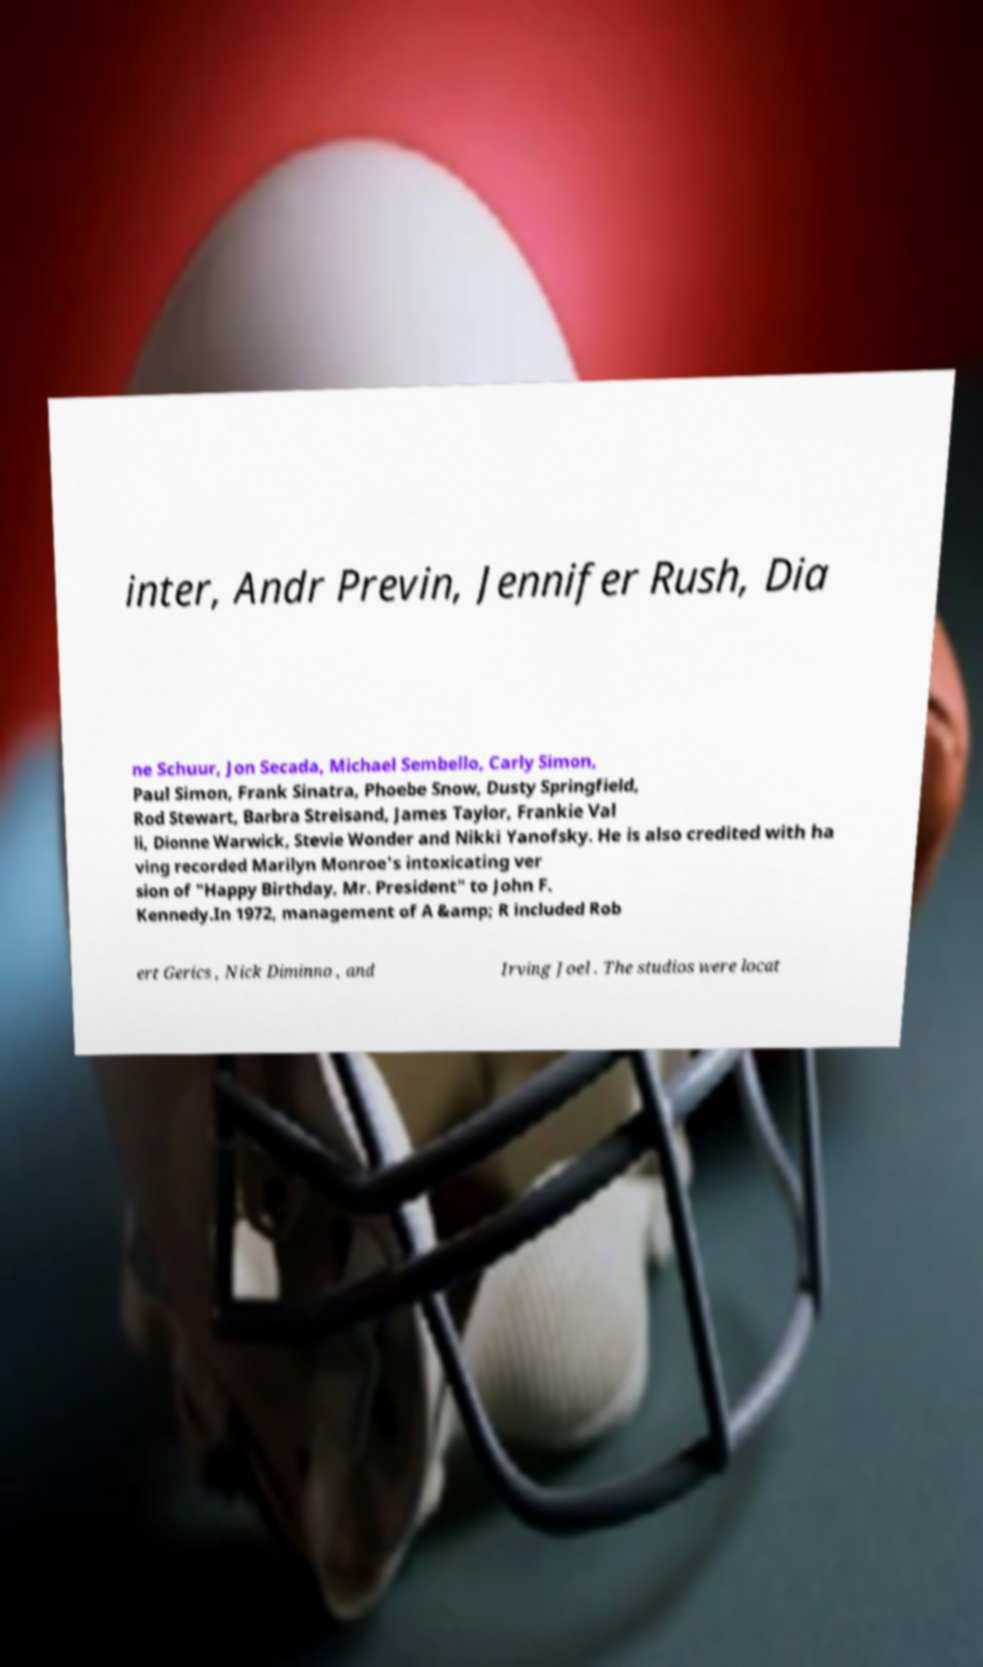Could you extract and type out the text from this image? inter, Andr Previn, Jennifer Rush, Dia ne Schuur, Jon Secada, Michael Sembello, Carly Simon, Paul Simon, Frank Sinatra, Phoebe Snow, Dusty Springfield, Rod Stewart, Barbra Streisand, James Taylor, Frankie Val li, Dionne Warwick, Stevie Wonder and Nikki Yanofsky. He is also credited with ha ving recorded Marilyn Monroe's intoxicating ver sion of "Happy Birthday, Mr. President" to John F. Kennedy.In 1972, management of A &amp; R included Rob ert Gerics , Nick Diminno , and Irving Joel . The studios were locat 